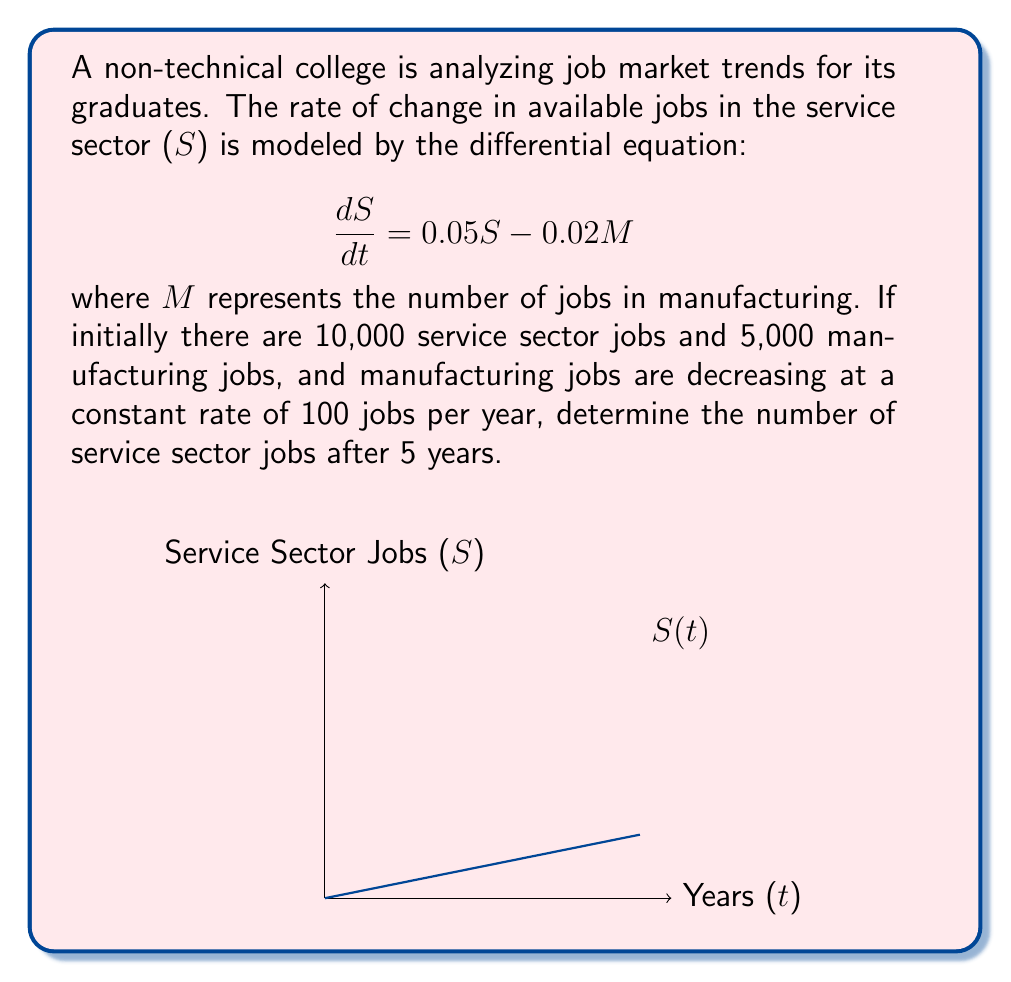Give your solution to this math problem. Let's approach this step-by-step:

1) We're given the differential equation: 
   $$\frac{dS}{dt} = 0.05S - 0.02M$$

2) We know that manufacturing jobs are decreasing at a constant rate of 100 per year. We can express this as:
   $$M(t) = 5000 - 100t$$

3) Substituting this into our original equation:
   $$\frac{dS}{dt} = 0.05S - 0.02(5000 - 100t) = 0.05S - 100 + 2t$$

4) This is a first-order linear differential equation. The general solution is:
   $$S(t) = ce^{0.05t} - 2000 + 40t$$
   where c is a constant we need to determine.

5) Using the initial condition S(0) = 10,000:
   $$10000 = c - 2000$$
   $$c = 12000$$

6) Therefore, our particular solution is:
   $$S(t) = 12000e^{0.05t} - 2000 + 40t$$

7) To find S(5), we substitute t = 5:
   $$S(5) = 12000e^{0.25} - 2000 + 40(5)$$
   $$= 12000(1.2840) - 2000 + 200$$
   $$= 15408 - 1800$$
   $$= 13608$$

8) Rounding to the nearest whole number (as we're dealing with jobs), we get 13,608 service sector jobs after 5 years.
Answer: 13,608 jobs 